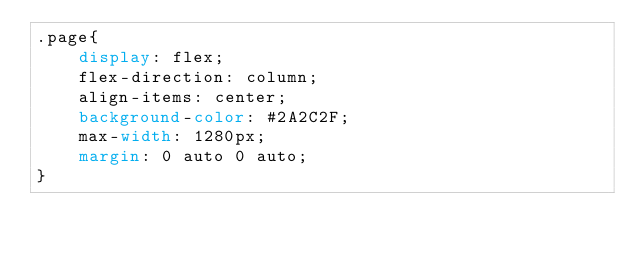<code> <loc_0><loc_0><loc_500><loc_500><_CSS_>.page{
    display: flex;
    flex-direction: column;
    align-items: center;
    background-color: #2A2C2F;
    max-width: 1280px;
    margin: 0 auto 0 auto;
}</code> 